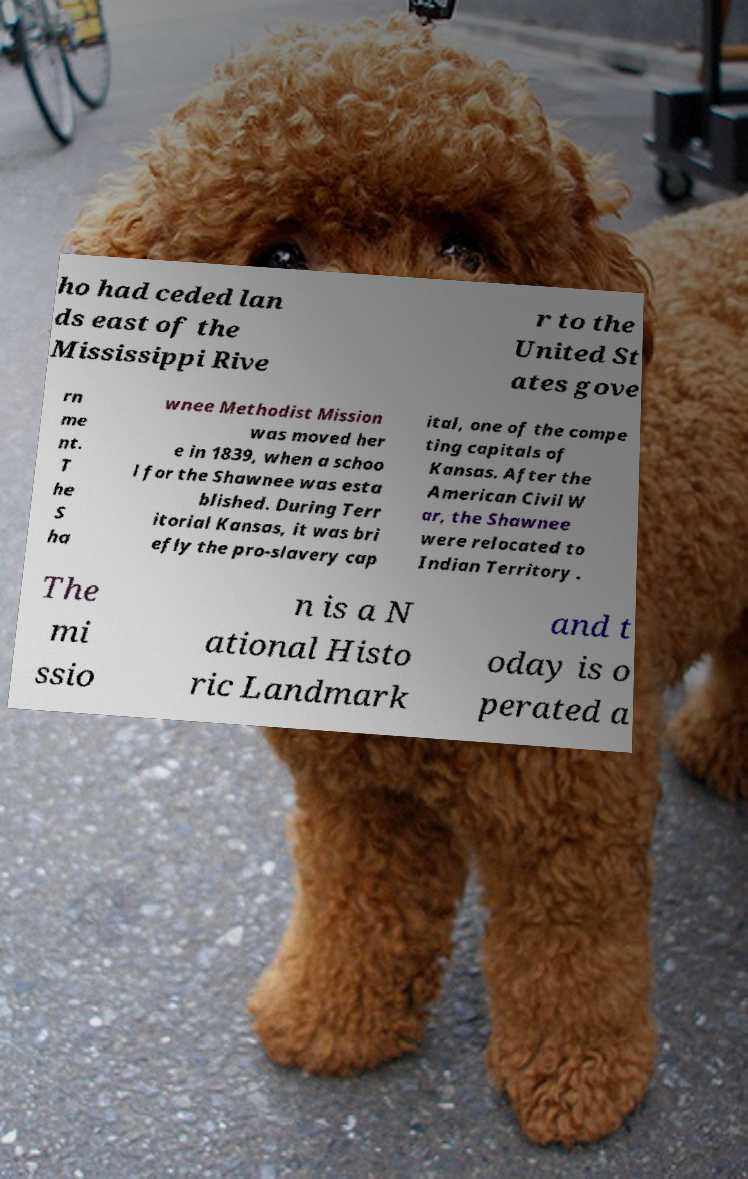Please read and relay the text visible in this image. What does it say? ho had ceded lan ds east of the Mississippi Rive r to the United St ates gove rn me nt. T he S ha wnee Methodist Mission was moved her e in 1839, when a schoo l for the Shawnee was esta blished. During Terr itorial Kansas, it was bri efly the pro-slavery cap ital, one of the compe ting capitals of Kansas. After the American Civil W ar, the Shawnee were relocated to Indian Territory . The mi ssio n is a N ational Histo ric Landmark and t oday is o perated a 